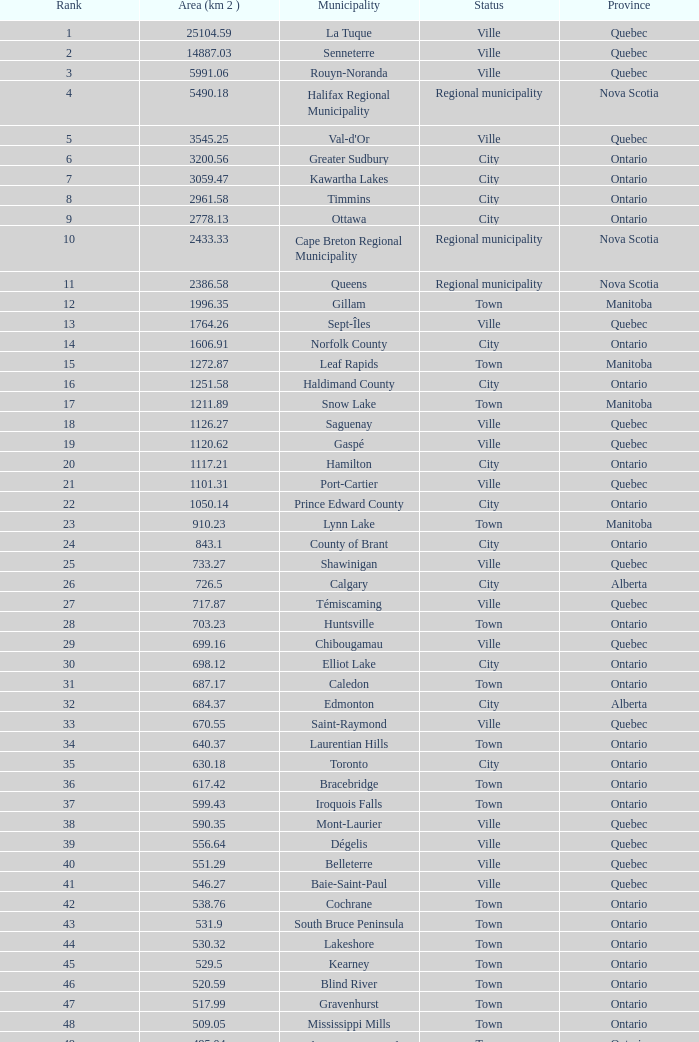What's the total of Rank that has an Area (KM 2) of 1050.14? 22.0. 